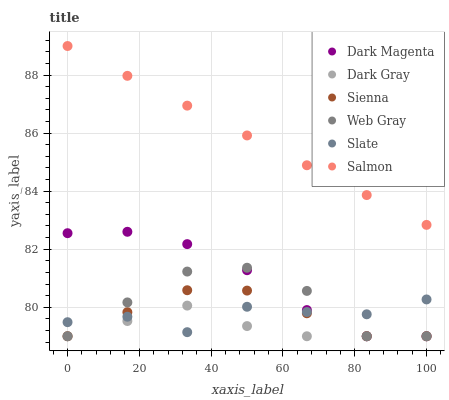Does Dark Gray have the minimum area under the curve?
Answer yes or no. Yes. Does Salmon have the maximum area under the curve?
Answer yes or no. Yes. Does Web Gray have the minimum area under the curve?
Answer yes or no. No. Does Web Gray have the maximum area under the curve?
Answer yes or no. No. Is Salmon the smoothest?
Answer yes or no. Yes. Is Web Gray the roughest?
Answer yes or no. Yes. Is Dark Magenta the smoothest?
Answer yes or no. No. Is Dark Magenta the roughest?
Answer yes or no. No. Does Sienna have the lowest value?
Answer yes or no. Yes. Does Slate have the lowest value?
Answer yes or no. No. Does Salmon have the highest value?
Answer yes or no. Yes. Does Web Gray have the highest value?
Answer yes or no. No. Is Dark Gray less than Salmon?
Answer yes or no. Yes. Is Salmon greater than Web Gray?
Answer yes or no. Yes. Does Sienna intersect Slate?
Answer yes or no. Yes. Is Sienna less than Slate?
Answer yes or no. No. Is Sienna greater than Slate?
Answer yes or no. No. Does Dark Gray intersect Salmon?
Answer yes or no. No. 